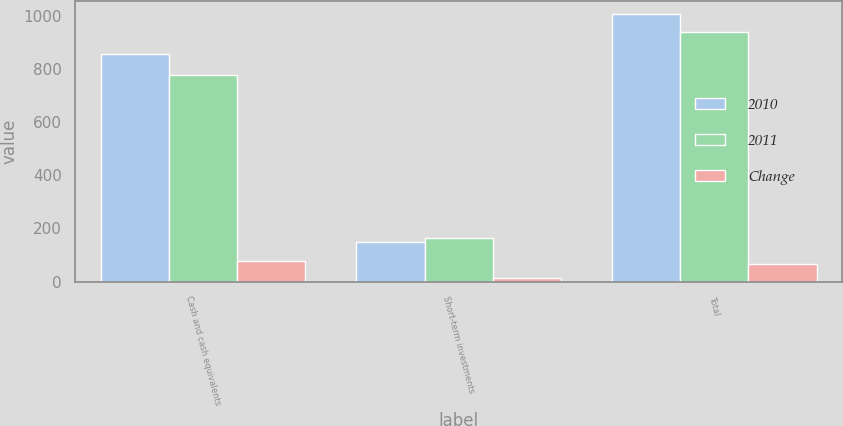Convert chart to OTSL. <chart><loc_0><loc_0><loc_500><loc_500><stacked_bar_chart><ecel><fcel>Cash and cash equivalents<fcel>Short-term investments<fcel>Total<nl><fcel>2010<fcel>855.1<fcel>149<fcel>1004.1<nl><fcel>2011<fcel>775.4<fcel>163.2<fcel>938.6<nl><fcel>Change<fcel>79.7<fcel>14.2<fcel>65.5<nl></chart> 